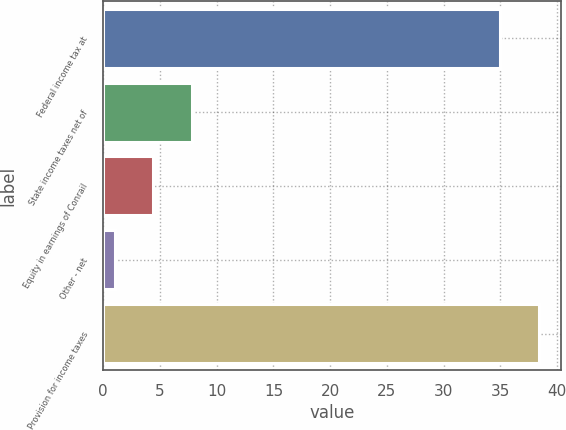Convert chart. <chart><loc_0><loc_0><loc_500><loc_500><bar_chart><fcel>Federal income tax at<fcel>State income taxes net of<fcel>Equity in earnings of Conrail<fcel>Other - net<fcel>Provision for income taxes<nl><fcel>35<fcel>7.8<fcel>4.4<fcel>1<fcel>38.4<nl></chart> 